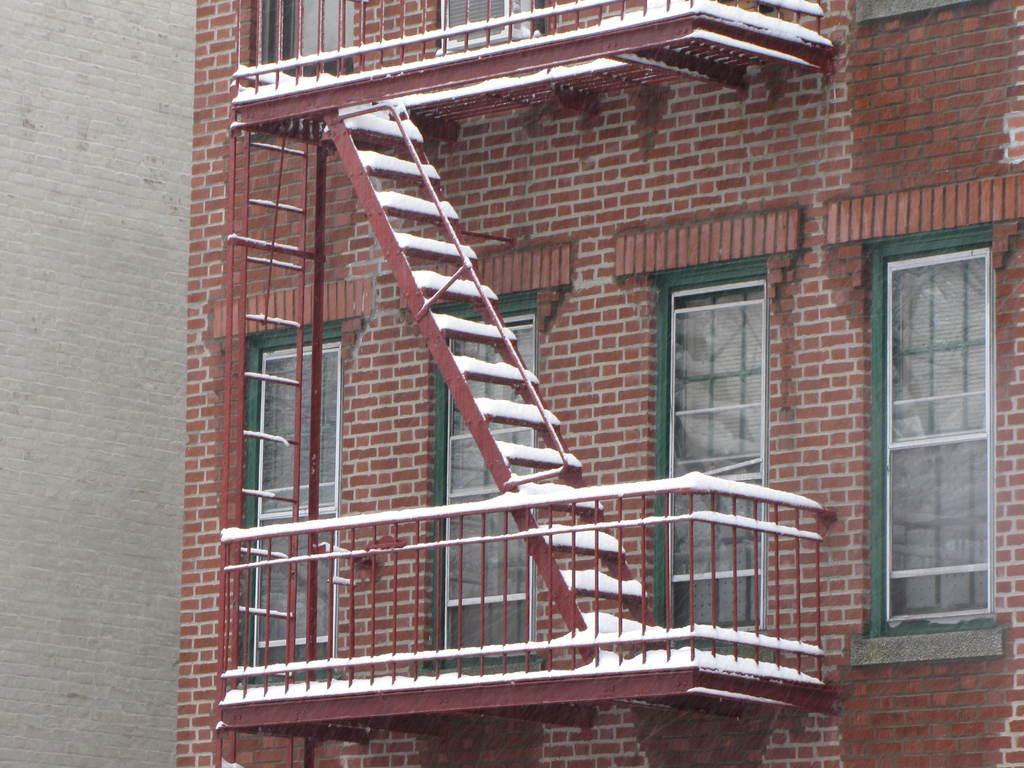Can you describe this image briefly? In the center of the image there is a building, brick wall, steps, windows and railings. 